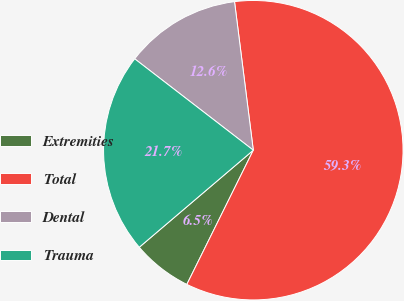Convert chart to OTSL. <chart><loc_0><loc_0><loc_500><loc_500><pie_chart><fcel>Extremities<fcel>Total<fcel>Dental<fcel>Trauma<nl><fcel>6.46%<fcel>59.32%<fcel>12.55%<fcel>21.67%<nl></chart> 